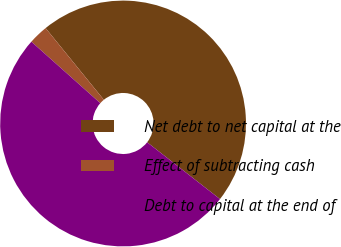Convert chart. <chart><loc_0><loc_0><loc_500><loc_500><pie_chart><fcel>Net debt to net capital at the<fcel>Effect of subtracting cash<fcel>Debt to capital at the end of<nl><fcel>46.4%<fcel>2.55%<fcel>51.05%<nl></chart> 